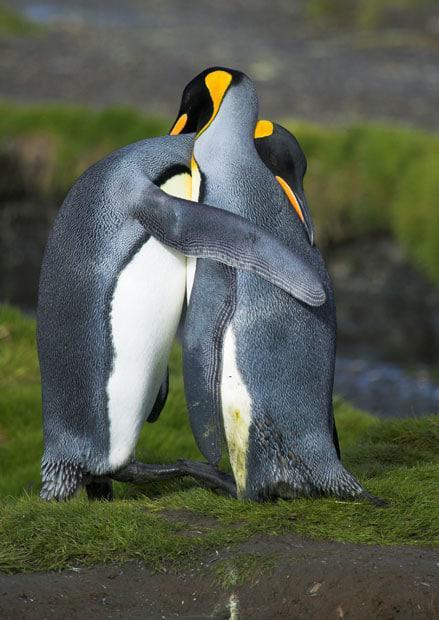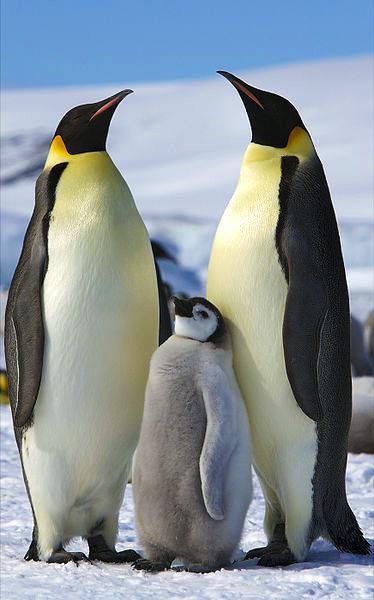The first image is the image on the left, the second image is the image on the right. For the images displayed, is the sentence "One image contains just one penguin." factually correct? Answer yes or no. No. The first image is the image on the left, the second image is the image on the right. Analyze the images presented: Is the assertion "There are five penguins" valid? Answer yes or no. Yes. 